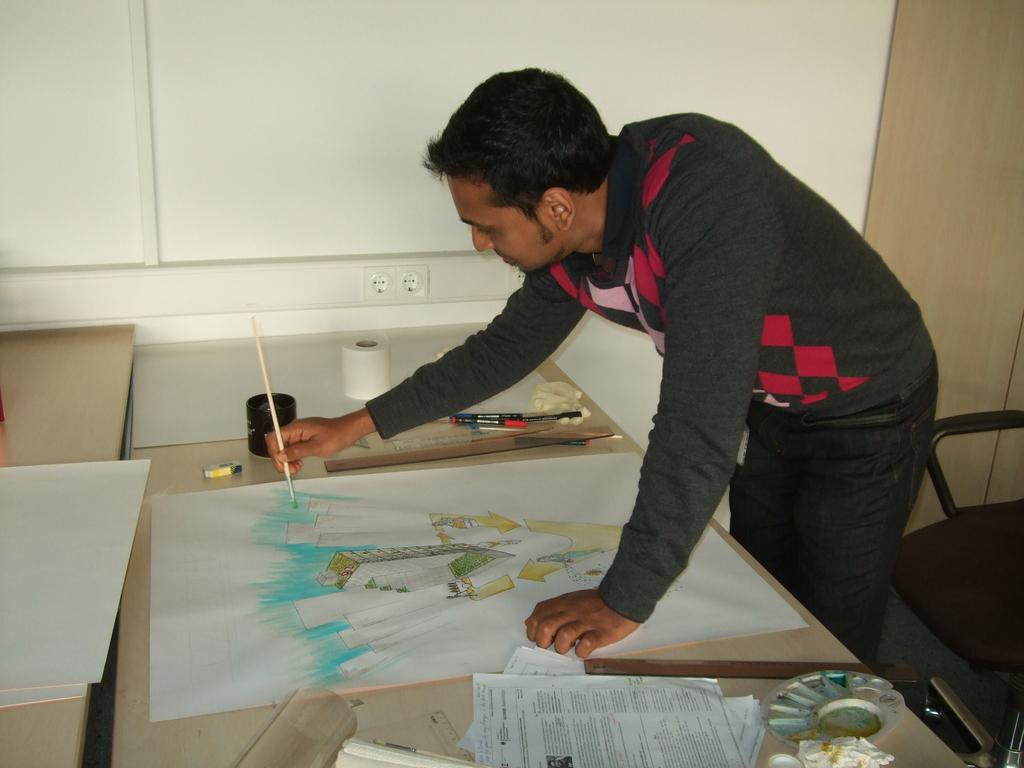What is the person in the image doing? The person is drawing a painting in the image. What surface is the person using for their artwork? The person is using paper as their canvas. Where is the paper placed while the person is drawing? The paper is placed on a table. What else can be seen on the table in the image? There are objects on the table. Can you describe the seating arrangement in the image? There is a chair on the right side of the image. What type of cracker is the person eating while drawing in the image? There is no cracker present in the image. What type of notebook is the person using to draw in the image? The person is using paper as their canvas, not a notebook. Is there a doctor present in the image? There is no mention of a doctor or any medical professional in the image. 